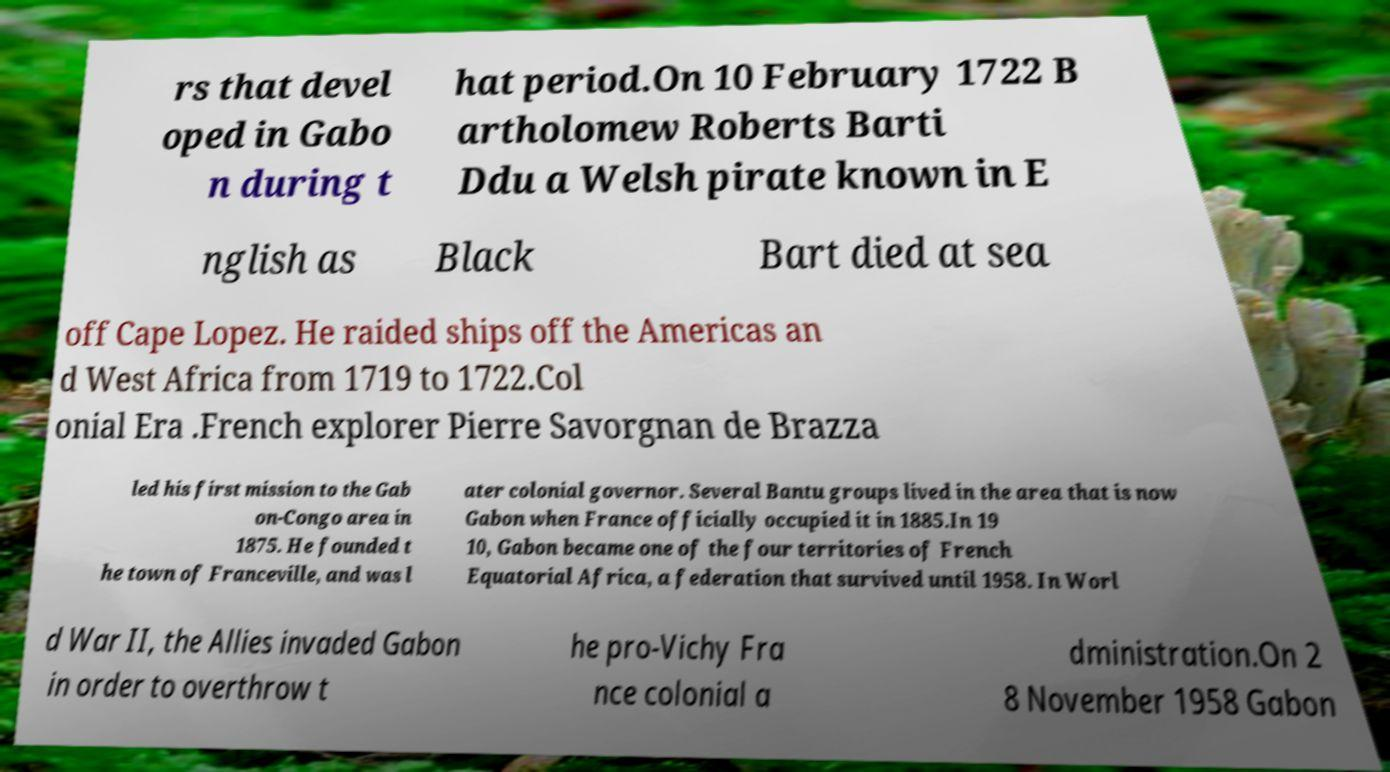Could you extract and type out the text from this image? rs that devel oped in Gabo n during t hat period.On 10 February 1722 B artholomew Roberts Barti Ddu a Welsh pirate known in E nglish as Black Bart died at sea off Cape Lopez. He raided ships off the Americas an d West Africa from 1719 to 1722.Col onial Era .French explorer Pierre Savorgnan de Brazza led his first mission to the Gab on-Congo area in 1875. He founded t he town of Franceville, and was l ater colonial governor. Several Bantu groups lived in the area that is now Gabon when France officially occupied it in 1885.In 19 10, Gabon became one of the four territories of French Equatorial Africa, a federation that survived until 1958. In Worl d War II, the Allies invaded Gabon in order to overthrow t he pro-Vichy Fra nce colonial a dministration.On 2 8 November 1958 Gabon 